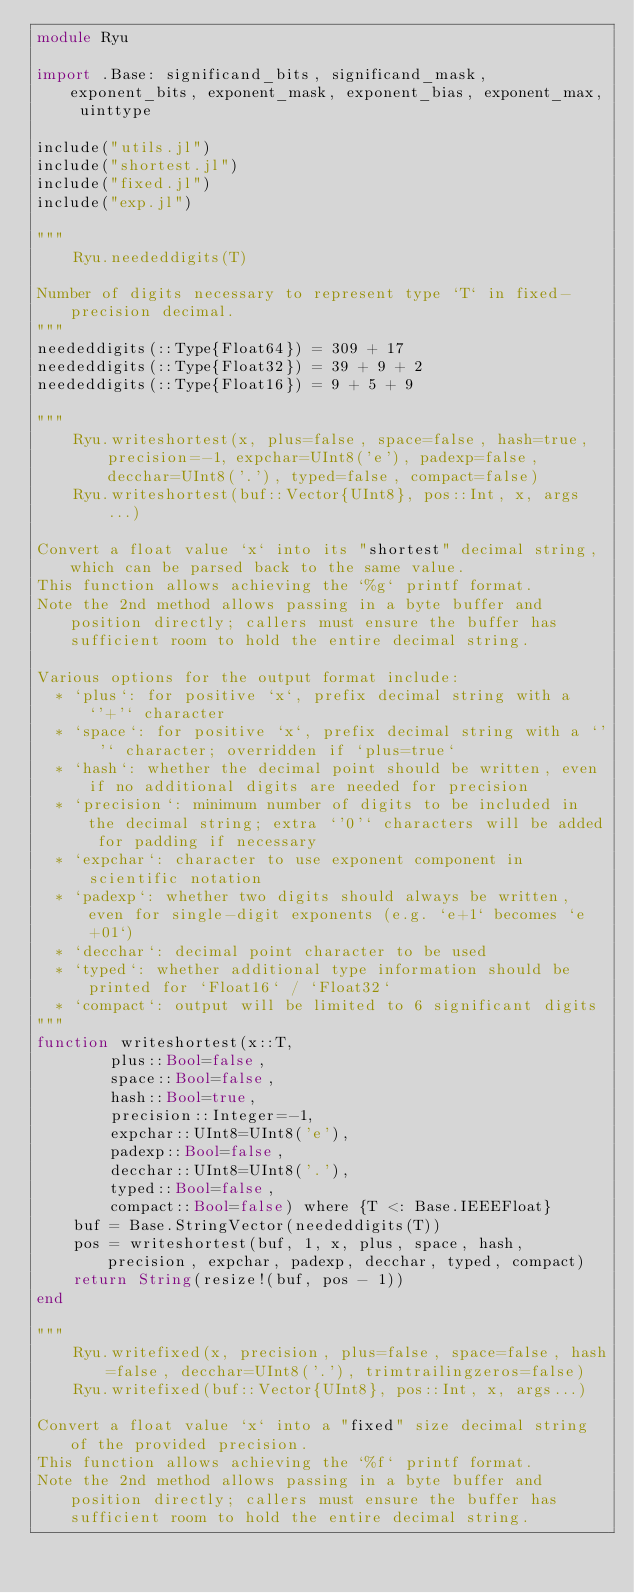Convert code to text. <code><loc_0><loc_0><loc_500><loc_500><_Julia_>module Ryu

import .Base: significand_bits, significand_mask, exponent_bits, exponent_mask, exponent_bias, exponent_max, uinttype

include("utils.jl")
include("shortest.jl")
include("fixed.jl")
include("exp.jl")

"""
    Ryu.neededdigits(T)

Number of digits necessary to represent type `T` in fixed-precision decimal.
"""
neededdigits(::Type{Float64}) = 309 + 17
neededdigits(::Type{Float32}) = 39 + 9 + 2
neededdigits(::Type{Float16}) = 9 + 5 + 9

"""
    Ryu.writeshortest(x, plus=false, space=false, hash=true, precision=-1, expchar=UInt8('e'), padexp=false, decchar=UInt8('.'), typed=false, compact=false)
    Ryu.writeshortest(buf::Vector{UInt8}, pos::Int, x, args...)

Convert a float value `x` into its "shortest" decimal string, which can be parsed back to the same value.
This function allows achieving the `%g` printf format.
Note the 2nd method allows passing in a byte buffer and position directly; callers must ensure the buffer has sufficient room to hold the entire decimal string.

Various options for the output format include:
  * `plus`: for positive `x`, prefix decimal string with a `'+'` character
  * `space`: for positive `x`, prefix decimal string with a `' '` character; overridden if `plus=true`
  * `hash`: whether the decimal point should be written, even if no additional digits are needed for precision
  * `precision`: minimum number of digits to be included in the decimal string; extra `'0'` characters will be added for padding if necessary
  * `expchar`: character to use exponent component in scientific notation
  * `padexp`: whether two digits should always be written, even for single-digit exponents (e.g. `e+1` becomes `e+01`)
  * `decchar`: decimal point character to be used
  * `typed`: whether additional type information should be printed for `Float16` / `Float32`
  * `compact`: output will be limited to 6 significant digits
"""
function writeshortest(x::T,
        plus::Bool=false,
        space::Bool=false,
        hash::Bool=true,
        precision::Integer=-1,
        expchar::UInt8=UInt8('e'),
        padexp::Bool=false,
        decchar::UInt8=UInt8('.'),
        typed::Bool=false,
        compact::Bool=false) where {T <: Base.IEEEFloat}
    buf = Base.StringVector(neededdigits(T))
    pos = writeshortest(buf, 1, x, plus, space, hash, precision, expchar, padexp, decchar, typed, compact)
    return String(resize!(buf, pos - 1))
end

"""
    Ryu.writefixed(x, precision, plus=false, space=false, hash=false, decchar=UInt8('.'), trimtrailingzeros=false)
    Ryu.writefixed(buf::Vector{UInt8}, pos::Int, x, args...)

Convert a float value `x` into a "fixed" size decimal string of the provided precision.
This function allows achieving the `%f` printf format.
Note the 2nd method allows passing in a byte buffer and position directly; callers must ensure the buffer has sufficient room to hold the entire decimal string.
</code> 